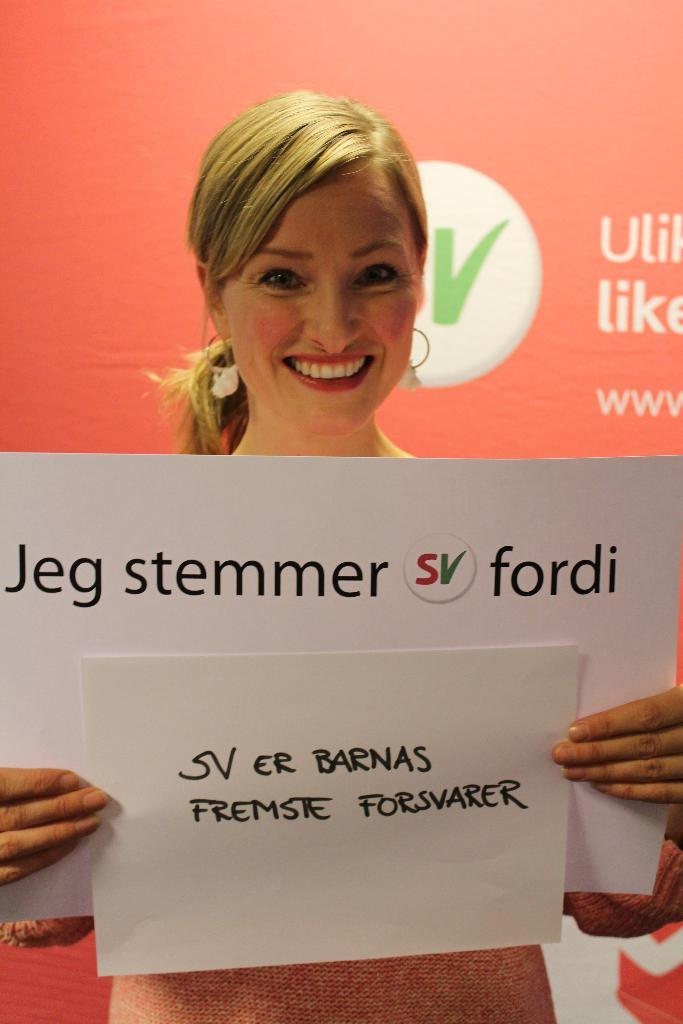Who is present in the image? There is a lady in the image. What is the lady doing in the image? The lady is smiling and holding papers. What can be seen in the background of the image? There is text visible in the background, and there is a logo on a board. What type of toothbrush is the lady using in the image? There is no toothbrush present in the image. Can you see a tail on the lady in the image? No, there is no tail visible on the lady in the image. 